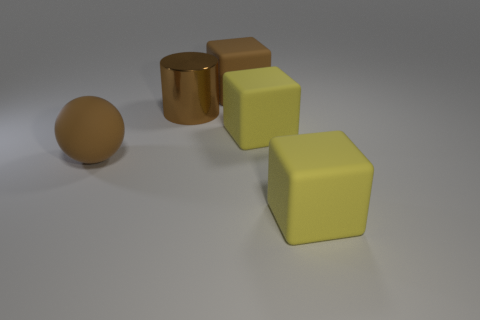Are there any other things that are made of the same material as the big cylinder?
Your response must be concise. No. Is there any other thing that is the same shape as the big brown shiny thing?
Make the answer very short. No. What shape is the yellow thing in front of the brown ball?
Your answer should be very brief. Cube. There is a matte cube that is in front of the matte sphere; is it the same size as the brown cube?
Provide a short and direct response. Yes. What number of rubber things are behind the big matte sphere?
Your response must be concise. 2. Is the number of cubes that are to the left of the brown sphere less than the number of large cylinders that are to the right of the large brown matte cube?
Your answer should be compact. No. How many large yellow cubes are there?
Offer a very short reply. 2. What is the color of the big object that is on the left side of the large shiny thing?
Make the answer very short. Brown. What size is the shiny cylinder?
Offer a terse response. Large. There is a metal object; is its color the same as the block that is behind the brown metallic cylinder?
Your response must be concise. Yes. 